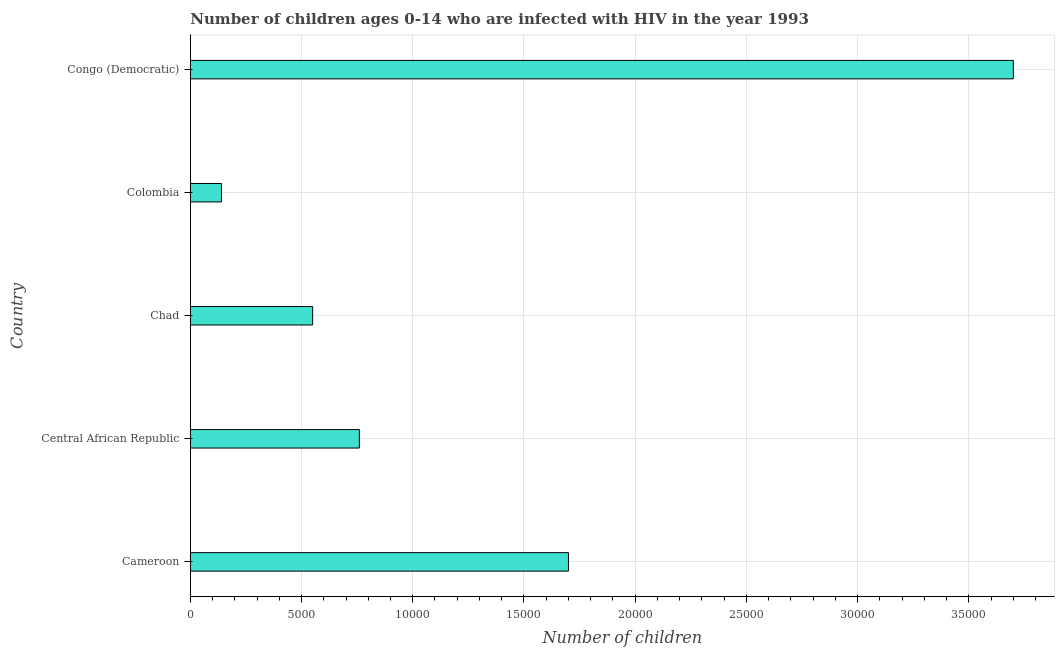What is the title of the graph?
Your response must be concise. Number of children ages 0-14 who are infected with HIV in the year 1993. What is the label or title of the X-axis?
Provide a short and direct response. Number of children. What is the label or title of the Y-axis?
Provide a succinct answer. Country. What is the number of children living with hiv in Colombia?
Offer a terse response. 1400. Across all countries, what is the maximum number of children living with hiv?
Ensure brevity in your answer.  3.70e+04. Across all countries, what is the minimum number of children living with hiv?
Offer a very short reply. 1400. In which country was the number of children living with hiv maximum?
Offer a terse response. Congo (Democratic). What is the sum of the number of children living with hiv?
Your answer should be compact. 6.85e+04. What is the difference between the number of children living with hiv in Cameroon and Chad?
Your answer should be compact. 1.15e+04. What is the average number of children living with hiv per country?
Provide a short and direct response. 1.37e+04. What is the median number of children living with hiv?
Your answer should be very brief. 7600. In how many countries, is the number of children living with hiv greater than 30000 ?
Provide a succinct answer. 1. What is the ratio of the number of children living with hiv in Cameroon to that in Chad?
Offer a terse response. 3.09. Is the sum of the number of children living with hiv in Colombia and Congo (Democratic) greater than the maximum number of children living with hiv across all countries?
Your answer should be very brief. Yes. What is the difference between the highest and the lowest number of children living with hiv?
Offer a terse response. 3.56e+04. In how many countries, is the number of children living with hiv greater than the average number of children living with hiv taken over all countries?
Ensure brevity in your answer.  2. How many bars are there?
Your response must be concise. 5. Are all the bars in the graph horizontal?
Provide a succinct answer. Yes. What is the Number of children in Cameroon?
Offer a terse response. 1.70e+04. What is the Number of children in Central African Republic?
Keep it short and to the point. 7600. What is the Number of children of Chad?
Your response must be concise. 5500. What is the Number of children of Colombia?
Your answer should be very brief. 1400. What is the Number of children of Congo (Democratic)?
Provide a succinct answer. 3.70e+04. What is the difference between the Number of children in Cameroon and Central African Republic?
Offer a terse response. 9400. What is the difference between the Number of children in Cameroon and Chad?
Offer a very short reply. 1.15e+04. What is the difference between the Number of children in Cameroon and Colombia?
Your answer should be very brief. 1.56e+04. What is the difference between the Number of children in Cameroon and Congo (Democratic)?
Make the answer very short. -2.00e+04. What is the difference between the Number of children in Central African Republic and Chad?
Provide a succinct answer. 2100. What is the difference between the Number of children in Central African Republic and Colombia?
Give a very brief answer. 6200. What is the difference between the Number of children in Central African Republic and Congo (Democratic)?
Provide a succinct answer. -2.94e+04. What is the difference between the Number of children in Chad and Colombia?
Your answer should be compact. 4100. What is the difference between the Number of children in Chad and Congo (Democratic)?
Keep it short and to the point. -3.15e+04. What is the difference between the Number of children in Colombia and Congo (Democratic)?
Keep it short and to the point. -3.56e+04. What is the ratio of the Number of children in Cameroon to that in Central African Republic?
Provide a short and direct response. 2.24. What is the ratio of the Number of children in Cameroon to that in Chad?
Offer a very short reply. 3.09. What is the ratio of the Number of children in Cameroon to that in Colombia?
Provide a succinct answer. 12.14. What is the ratio of the Number of children in Cameroon to that in Congo (Democratic)?
Offer a terse response. 0.46. What is the ratio of the Number of children in Central African Republic to that in Chad?
Offer a very short reply. 1.38. What is the ratio of the Number of children in Central African Republic to that in Colombia?
Keep it short and to the point. 5.43. What is the ratio of the Number of children in Central African Republic to that in Congo (Democratic)?
Offer a very short reply. 0.2. What is the ratio of the Number of children in Chad to that in Colombia?
Provide a succinct answer. 3.93. What is the ratio of the Number of children in Chad to that in Congo (Democratic)?
Your answer should be compact. 0.15. What is the ratio of the Number of children in Colombia to that in Congo (Democratic)?
Keep it short and to the point. 0.04. 